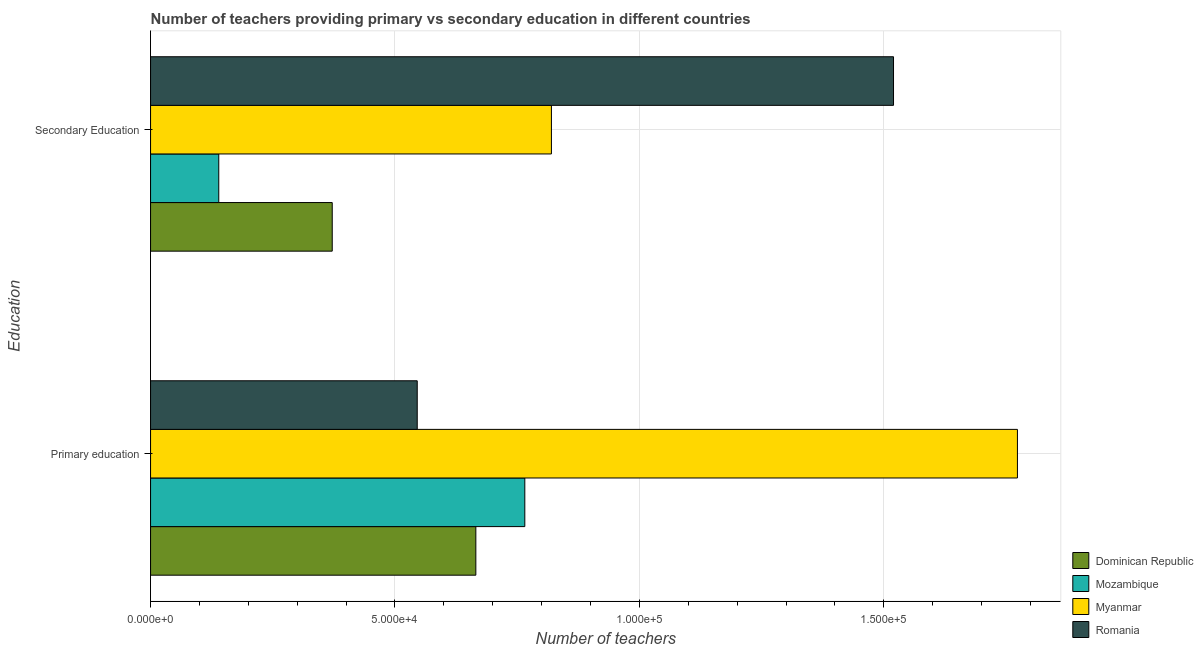How many groups of bars are there?
Make the answer very short. 2. Are the number of bars per tick equal to the number of legend labels?
Your answer should be compact. Yes. Are the number of bars on each tick of the Y-axis equal?
Keep it short and to the point. Yes. How many bars are there on the 1st tick from the top?
Provide a short and direct response. 4. What is the label of the 2nd group of bars from the top?
Provide a succinct answer. Primary education. What is the number of secondary teachers in Myanmar?
Offer a very short reply. 8.20e+04. Across all countries, what is the maximum number of primary teachers?
Your response must be concise. 1.77e+05. Across all countries, what is the minimum number of primary teachers?
Your response must be concise. 5.46e+04. In which country was the number of primary teachers maximum?
Your answer should be very brief. Myanmar. In which country was the number of primary teachers minimum?
Offer a very short reply. Romania. What is the total number of primary teachers in the graph?
Your answer should be compact. 3.75e+05. What is the difference between the number of secondary teachers in Myanmar and that in Romania?
Provide a succinct answer. -7.00e+04. What is the difference between the number of secondary teachers in Romania and the number of primary teachers in Mozambique?
Give a very brief answer. 7.54e+04. What is the average number of secondary teachers per country?
Your answer should be compact. 7.13e+04. What is the difference between the number of secondary teachers and number of primary teachers in Romania?
Keep it short and to the point. 9.74e+04. In how many countries, is the number of primary teachers greater than 80000 ?
Keep it short and to the point. 1. What is the ratio of the number of secondary teachers in Dominican Republic to that in Romania?
Offer a terse response. 0.24. In how many countries, is the number of primary teachers greater than the average number of primary teachers taken over all countries?
Your response must be concise. 1. What does the 4th bar from the top in Secondary Education represents?
Provide a short and direct response. Dominican Republic. What does the 3rd bar from the bottom in Secondary Education represents?
Provide a succinct answer. Myanmar. How many countries are there in the graph?
Your answer should be compact. 4. Are the values on the major ticks of X-axis written in scientific E-notation?
Your answer should be compact. Yes. Does the graph contain any zero values?
Ensure brevity in your answer.  No. What is the title of the graph?
Provide a succinct answer. Number of teachers providing primary vs secondary education in different countries. What is the label or title of the X-axis?
Provide a succinct answer. Number of teachers. What is the label or title of the Y-axis?
Your answer should be compact. Education. What is the Number of teachers of Dominican Republic in Primary education?
Make the answer very short. 6.65e+04. What is the Number of teachers in Mozambique in Primary education?
Your answer should be compact. 7.66e+04. What is the Number of teachers in Myanmar in Primary education?
Make the answer very short. 1.77e+05. What is the Number of teachers of Romania in Primary education?
Make the answer very short. 5.46e+04. What is the Number of teachers of Dominican Republic in Secondary Education?
Ensure brevity in your answer.  3.72e+04. What is the Number of teachers of Mozambique in Secondary Education?
Provide a short and direct response. 1.40e+04. What is the Number of teachers of Myanmar in Secondary Education?
Keep it short and to the point. 8.20e+04. What is the Number of teachers of Romania in Secondary Education?
Provide a succinct answer. 1.52e+05. Across all Education, what is the maximum Number of teachers in Dominican Republic?
Offer a very short reply. 6.65e+04. Across all Education, what is the maximum Number of teachers in Mozambique?
Your answer should be compact. 7.66e+04. Across all Education, what is the maximum Number of teachers in Myanmar?
Ensure brevity in your answer.  1.77e+05. Across all Education, what is the maximum Number of teachers in Romania?
Your answer should be compact. 1.52e+05. Across all Education, what is the minimum Number of teachers of Dominican Republic?
Ensure brevity in your answer.  3.72e+04. Across all Education, what is the minimum Number of teachers of Mozambique?
Give a very brief answer. 1.40e+04. Across all Education, what is the minimum Number of teachers in Myanmar?
Offer a terse response. 8.20e+04. Across all Education, what is the minimum Number of teachers of Romania?
Ensure brevity in your answer.  5.46e+04. What is the total Number of teachers of Dominican Republic in the graph?
Your answer should be very brief. 1.04e+05. What is the total Number of teachers of Mozambique in the graph?
Give a very brief answer. 9.05e+04. What is the total Number of teachers in Myanmar in the graph?
Provide a succinct answer. 2.59e+05. What is the total Number of teachers of Romania in the graph?
Make the answer very short. 2.07e+05. What is the difference between the Number of teachers in Dominican Republic in Primary education and that in Secondary Education?
Give a very brief answer. 2.94e+04. What is the difference between the Number of teachers in Mozambique in Primary education and that in Secondary Education?
Your answer should be compact. 6.26e+04. What is the difference between the Number of teachers in Myanmar in Primary education and that in Secondary Education?
Offer a very short reply. 9.53e+04. What is the difference between the Number of teachers in Romania in Primary education and that in Secondary Education?
Your answer should be compact. -9.74e+04. What is the difference between the Number of teachers in Dominican Republic in Primary education and the Number of teachers in Mozambique in Secondary Education?
Your answer should be very brief. 5.26e+04. What is the difference between the Number of teachers in Dominican Republic in Primary education and the Number of teachers in Myanmar in Secondary Education?
Provide a succinct answer. -1.55e+04. What is the difference between the Number of teachers in Dominican Republic in Primary education and the Number of teachers in Romania in Secondary Education?
Make the answer very short. -8.54e+04. What is the difference between the Number of teachers of Mozambique in Primary education and the Number of teachers of Myanmar in Secondary Education?
Keep it short and to the point. -5443. What is the difference between the Number of teachers in Mozambique in Primary education and the Number of teachers in Romania in Secondary Education?
Ensure brevity in your answer.  -7.54e+04. What is the difference between the Number of teachers of Myanmar in Primary education and the Number of teachers of Romania in Secondary Education?
Your answer should be very brief. 2.54e+04. What is the average Number of teachers of Dominican Republic per Education?
Ensure brevity in your answer.  5.19e+04. What is the average Number of teachers in Mozambique per Education?
Offer a very short reply. 4.53e+04. What is the average Number of teachers in Myanmar per Education?
Your answer should be compact. 1.30e+05. What is the average Number of teachers of Romania per Education?
Give a very brief answer. 1.03e+05. What is the difference between the Number of teachers of Dominican Republic and Number of teachers of Mozambique in Primary education?
Your answer should be compact. -1.00e+04. What is the difference between the Number of teachers in Dominican Republic and Number of teachers in Myanmar in Primary education?
Offer a terse response. -1.11e+05. What is the difference between the Number of teachers in Dominican Republic and Number of teachers in Romania in Primary education?
Provide a succinct answer. 1.20e+04. What is the difference between the Number of teachers in Mozambique and Number of teachers in Myanmar in Primary education?
Your answer should be compact. -1.01e+05. What is the difference between the Number of teachers in Mozambique and Number of teachers in Romania in Primary education?
Your answer should be compact. 2.20e+04. What is the difference between the Number of teachers of Myanmar and Number of teachers of Romania in Primary education?
Offer a terse response. 1.23e+05. What is the difference between the Number of teachers of Dominican Republic and Number of teachers of Mozambique in Secondary Education?
Your answer should be compact. 2.32e+04. What is the difference between the Number of teachers in Dominican Republic and Number of teachers in Myanmar in Secondary Education?
Ensure brevity in your answer.  -4.48e+04. What is the difference between the Number of teachers in Dominican Republic and Number of teachers in Romania in Secondary Education?
Your answer should be very brief. -1.15e+05. What is the difference between the Number of teachers of Mozambique and Number of teachers of Myanmar in Secondary Education?
Provide a succinct answer. -6.80e+04. What is the difference between the Number of teachers in Mozambique and Number of teachers in Romania in Secondary Education?
Your answer should be compact. -1.38e+05. What is the difference between the Number of teachers in Myanmar and Number of teachers in Romania in Secondary Education?
Make the answer very short. -7.00e+04. What is the ratio of the Number of teachers of Dominican Republic in Primary education to that in Secondary Education?
Offer a terse response. 1.79. What is the ratio of the Number of teachers in Mozambique in Primary education to that in Secondary Education?
Offer a terse response. 5.49. What is the ratio of the Number of teachers in Myanmar in Primary education to that in Secondary Education?
Offer a terse response. 2.16. What is the ratio of the Number of teachers in Romania in Primary education to that in Secondary Education?
Provide a short and direct response. 0.36. What is the difference between the highest and the second highest Number of teachers of Dominican Republic?
Keep it short and to the point. 2.94e+04. What is the difference between the highest and the second highest Number of teachers of Mozambique?
Keep it short and to the point. 6.26e+04. What is the difference between the highest and the second highest Number of teachers of Myanmar?
Your response must be concise. 9.53e+04. What is the difference between the highest and the second highest Number of teachers of Romania?
Provide a succinct answer. 9.74e+04. What is the difference between the highest and the lowest Number of teachers in Dominican Republic?
Offer a terse response. 2.94e+04. What is the difference between the highest and the lowest Number of teachers of Mozambique?
Your answer should be compact. 6.26e+04. What is the difference between the highest and the lowest Number of teachers in Myanmar?
Offer a terse response. 9.53e+04. What is the difference between the highest and the lowest Number of teachers of Romania?
Provide a short and direct response. 9.74e+04. 